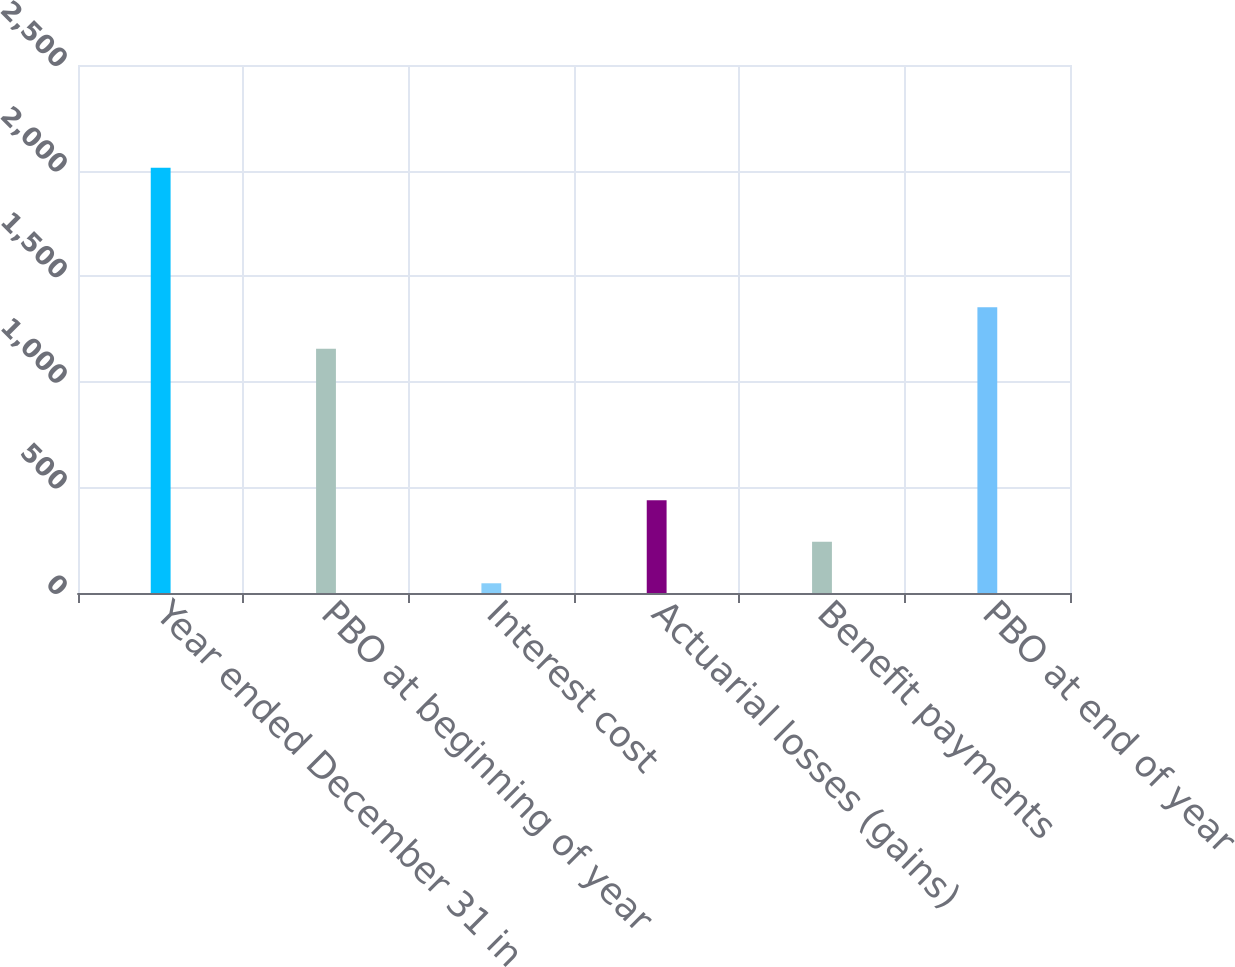Convert chart. <chart><loc_0><loc_0><loc_500><loc_500><bar_chart><fcel>Year ended December 31 in<fcel>PBO at beginning of year<fcel>Interest cost<fcel>Actuarial losses (gains)<fcel>Benefit payments<fcel>PBO at end of year<nl><fcel>2014<fcel>1156<fcel>46<fcel>439.6<fcel>242.8<fcel>1352.8<nl></chart> 